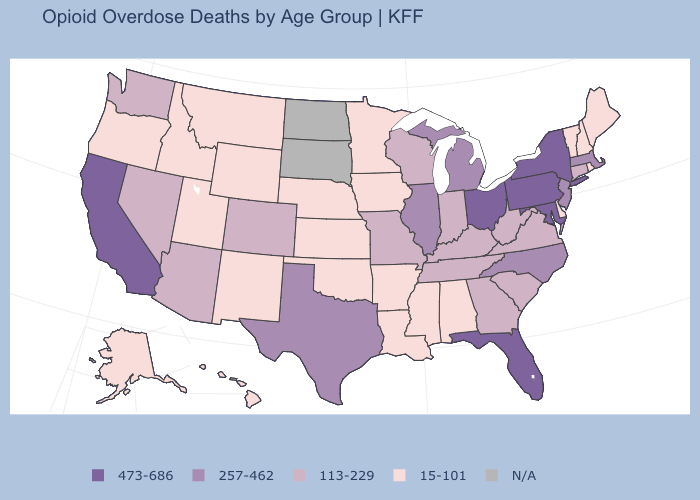Among the states that border Connecticut , does Rhode Island have the lowest value?
Concise answer only. Yes. Does California have the highest value in the West?
Be succinct. Yes. Does Ohio have the highest value in the MidWest?
Answer briefly. Yes. What is the value of Kentucky?
Be succinct. 113-229. What is the value of New York?
Give a very brief answer. 473-686. Name the states that have a value in the range 15-101?
Give a very brief answer. Alabama, Alaska, Arkansas, Delaware, Hawaii, Idaho, Iowa, Kansas, Louisiana, Maine, Minnesota, Mississippi, Montana, Nebraska, New Hampshire, New Mexico, Oklahoma, Oregon, Rhode Island, Utah, Vermont, Wyoming. Which states have the highest value in the USA?
Keep it brief. California, Florida, Maryland, New York, Ohio, Pennsylvania. What is the value of Oregon?
Answer briefly. 15-101. What is the value of Tennessee?
Keep it brief. 113-229. What is the value of Michigan?
Answer briefly. 257-462. Does Rhode Island have the lowest value in the Northeast?
Keep it brief. Yes. Name the states that have a value in the range 473-686?
Give a very brief answer. California, Florida, Maryland, New York, Ohio, Pennsylvania. Does Michigan have the highest value in the MidWest?
Concise answer only. No. 